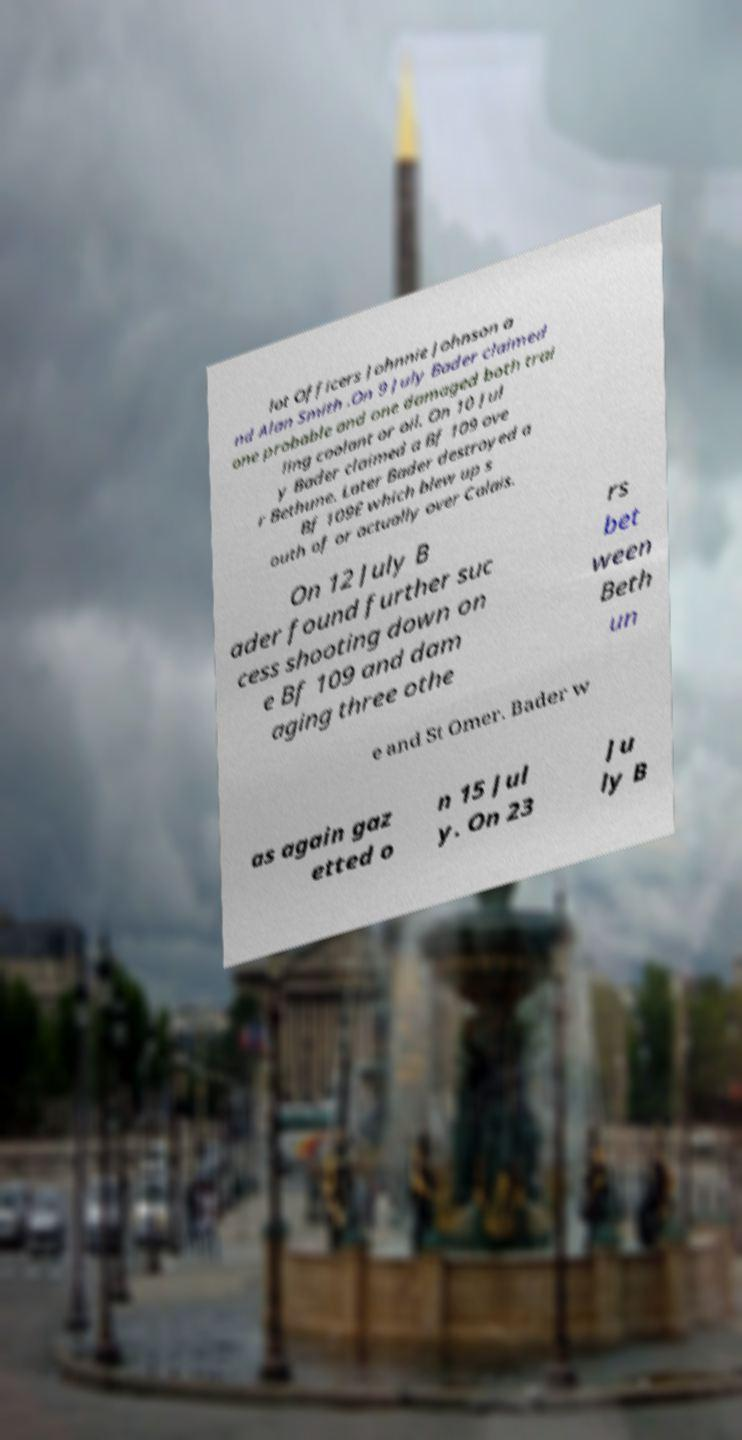Can you read and provide the text displayed in the image?This photo seems to have some interesting text. Can you extract and type it out for me? lot Officers Johnnie Johnson a nd Alan Smith .On 9 July Bader claimed one probable and one damaged both trai ling coolant or oil. On 10 Jul y Bader claimed a Bf 109 ove r Bethune. Later Bader destroyed a Bf 109E which blew up s outh of or actually over Calais. On 12 July B ader found further suc cess shooting down on e Bf 109 and dam aging three othe rs bet ween Beth un e and St Omer. Bader w as again gaz etted o n 15 Jul y. On 23 Ju ly B 